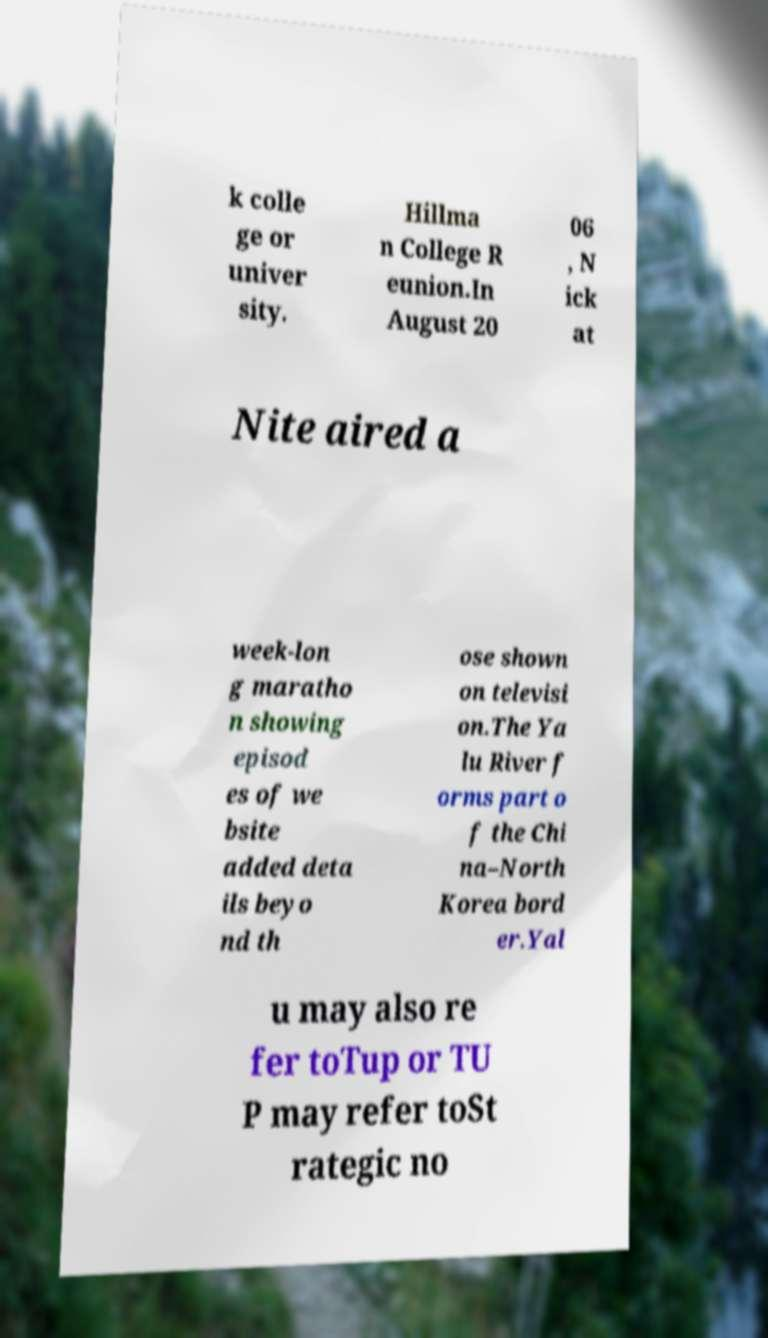I need the written content from this picture converted into text. Can you do that? k colle ge or univer sity. Hillma n College R eunion.In August 20 06 , N ick at Nite aired a week-lon g maratho n showing episod es of we bsite added deta ils beyo nd th ose shown on televisi on.The Ya lu River f orms part o f the Chi na–North Korea bord er.Yal u may also re fer toTup or TU P may refer toSt rategic no 